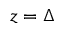<formula> <loc_0><loc_0><loc_500><loc_500>z = \Delta</formula> 